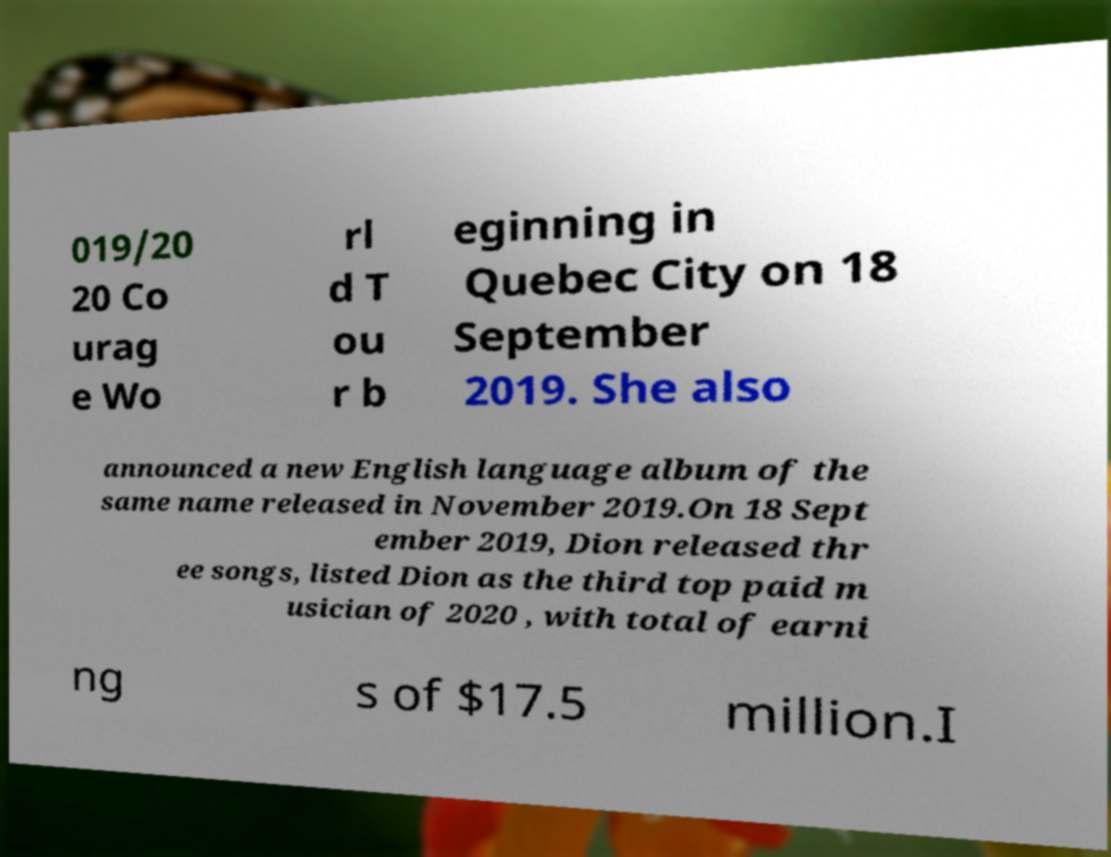I need the written content from this picture converted into text. Can you do that? 019/20 20 Co urag e Wo rl d T ou r b eginning in Quebec City on 18 September 2019. She also announced a new English language album of the same name released in November 2019.On 18 Sept ember 2019, Dion released thr ee songs, listed Dion as the third top paid m usician of 2020 , with total of earni ng s of $17.5 million.I 